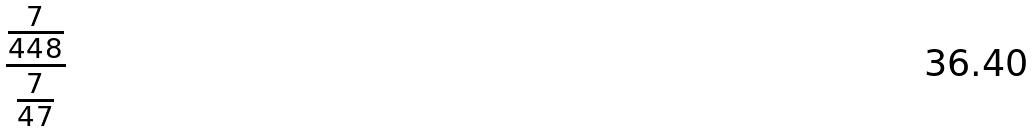Convert formula to latex. <formula><loc_0><loc_0><loc_500><loc_500>\frac { \frac { 7 } { 4 4 8 } } { \frac { 7 } { 4 7 } }</formula> 